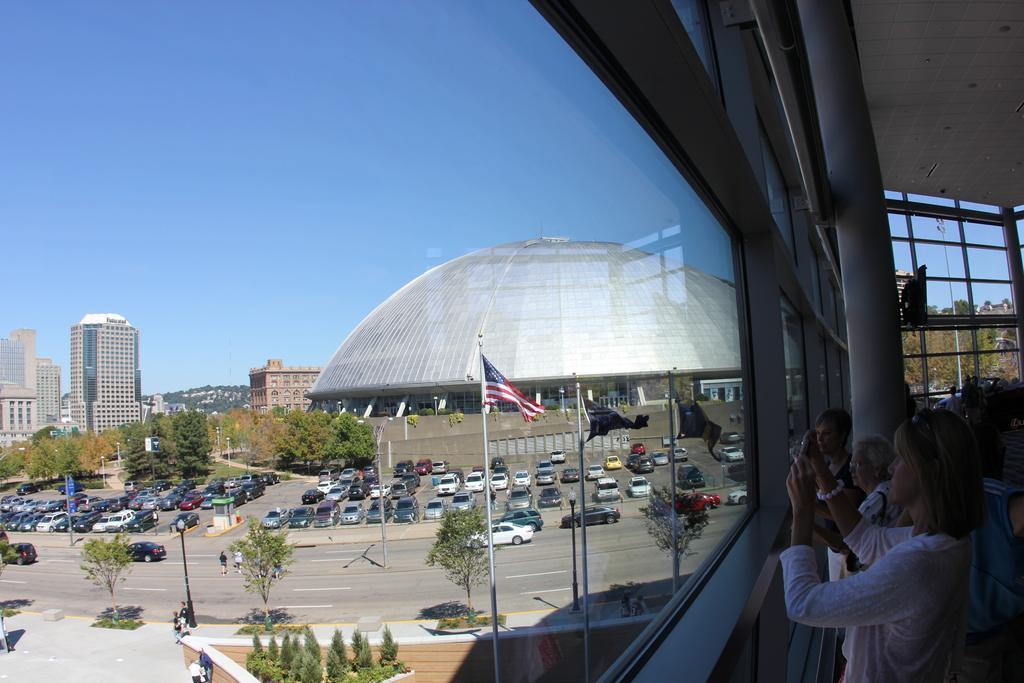Describe this image in one or two sentences. In this image I can see a building, in front of building I can see trees , vehicles, there is a road, on which I can see persons and vehicles, trees in the middle, at the bottom I can see persons and trees and on the right side I can see building inside the building I can see few persons and a woman holding camera taking the picture, at the top I can see the sky. 